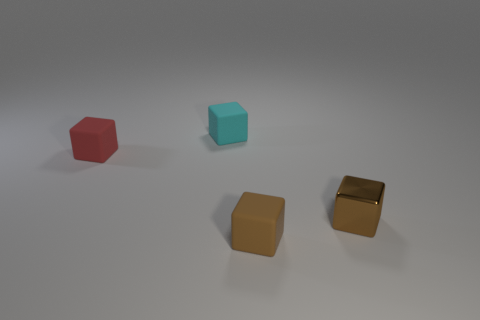The other small metal thing that is the same shape as the red object is what color?
Provide a short and direct response. Brown. Is there a rubber thing in front of the rubber cube that is in front of the red cube?
Give a very brief answer. No. How big is the shiny object?
Offer a very short reply. Small. What is the shape of the small rubber thing that is to the right of the tiny red rubber cube and on the left side of the tiny brown matte cube?
Your answer should be compact. Cube. What number of blue objects are either tiny matte things or tiny shiny objects?
Offer a terse response. 0. Do the thing in front of the shiny thing and the rubber block that is left of the cyan rubber block have the same size?
Offer a terse response. Yes. How many objects are gray metal balls or brown metallic blocks?
Ensure brevity in your answer.  1. Are there any other things of the same shape as the metallic thing?
Provide a succinct answer. Yes. Is the number of large purple metallic spheres less than the number of cyan blocks?
Give a very brief answer. Yes. Do the small cyan rubber object and the tiny red object have the same shape?
Your answer should be compact. Yes. 